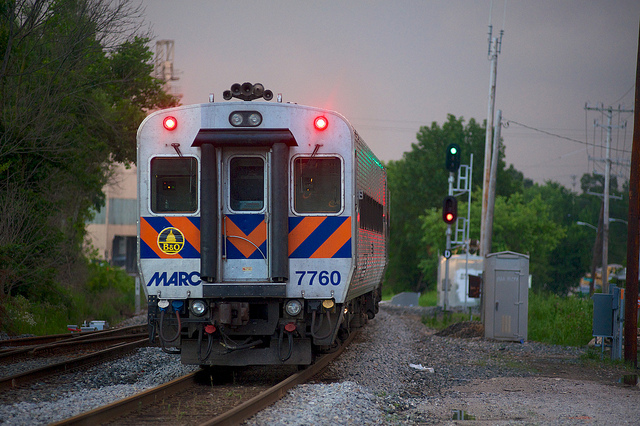<image>What is the no written on the train? I don't know what no is written on the train. It could be '7760' or 'marc'. How many people are on the train? It's uncertain how many people are on the train. It may vary as there are multiple responses. What is the no written on the train? The no written on the train is '7760'. How many people are on the train? I don't know how many people are on the train. It can be any number between 0 and many. 